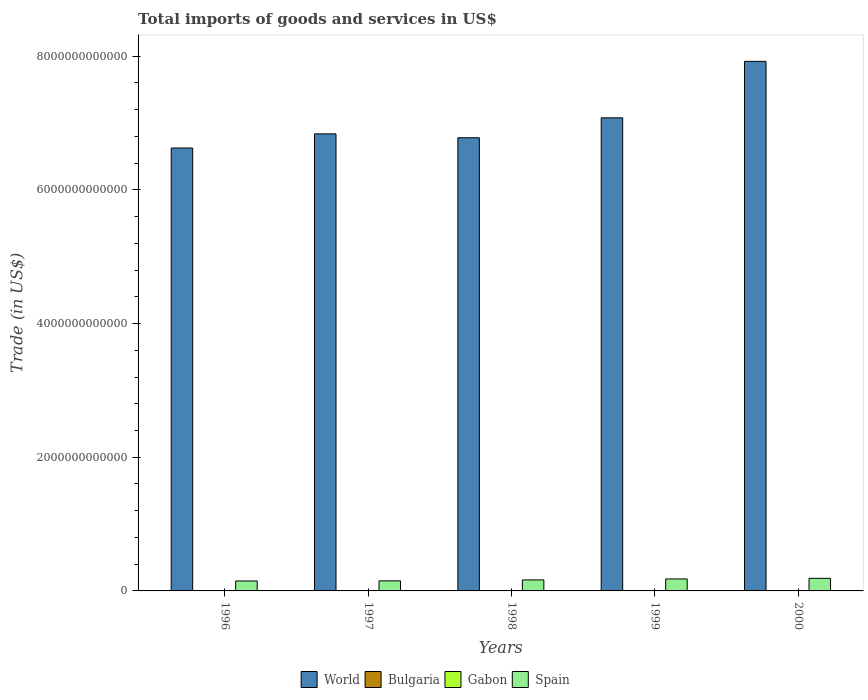How many different coloured bars are there?
Offer a terse response. 4. Are the number of bars per tick equal to the number of legend labels?
Offer a terse response. Yes. Are the number of bars on each tick of the X-axis equal?
Your answer should be compact. Yes. How many bars are there on the 4th tick from the left?
Your response must be concise. 4. How many bars are there on the 4th tick from the right?
Keep it short and to the point. 4. What is the label of the 4th group of bars from the left?
Keep it short and to the point. 1999. In how many cases, is the number of bars for a given year not equal to the number of legend labels?
Your response must be concise. 0. What is the total imports of goods and services in Gabon in 2000?
Offer a very short reply. 1.66e+09. Across all years, what is the maximum total imports of goods and services in Gabon?
Ensure brevity in your answer.  2.18e+09. Across all years, what is the minimum total imports of goods and services in World?
Your answer should be very brief. 6.63e+12. In which year was the total imports of goods and services in Spain maximum?
Give a very brief answer. 2000. What is the total total imports of goods and services in Bulgaria in the graph?
Provide a succinct answer. 2.60e+1. What is the difference between the total imports of goods and services in Bulgaria in 1997 and that in 1998?
Ensure brevity in your answer.  -1.10e+09. What is the difference between the total imports of goods and services in World in 1998 and the total imports of goods and services in Spain in 1996?
Give a very brief answer. 6.63e+12. What is the average total imports of goods and services in World per year?
Provide a succinct answer. 7.05e+12. In the year 2000, what is the difference between the total imports of goods and services in Spain and total imports of goods and services in Bulgaria?
Offer a terse response. 1.83e+11. What is the ratio of the total imports of goods and services in World in 1998 to that in 1999?
Provide a succinct answer. 0.96. Is the total imports of goods and services in Spain in 1998 less than that in 2000?
Your answer should be compact. Yes. Is the difference between the total imports of goods and services in Spain in 1996 and 1999 greater than the difference between the total imports of goods and services in Bulgaria in 1996 and 1999?
Provide a succinct answer. No. What is the difference between the highest and the second highest total imports of goods and services in Gabon?
Ensure brevity in your answer.  1.94e+08. What is the difference between the highest and the lowest total imports of goods and services in Bulgaria?
Make the answer very short. 2.27e+09. In how many years, is the total imports of goods and services in World greater than the average total imports of goods and services in World taken over all years?
Provide a short and direct response. 2. Is it the case that in every year, the sum of the total imports of goods and services in Spain and total imports of goods and services in World is greater than the sum of total imports of goods and services in Gabon and total imports of goods and services in Bulgaria?
Keep it short and to the point. Yes. What does the 3rd bar from the left in 1997 represents?
Your answer should be compact. Gabon. Is it the case that in every year, the sum of the total imports of goods and services in Bulgaria and total imports of goods and services in Gabon is greater than the total imports of goods and services in World?
Make the answer very short. No. What is the difference between two consecutive major ticks on the Y-axis?
Your answer should be compact. 2.00e+12. Does the graph contain any zero values?
Keep it short and to the point. No. How are the legend labels stacked?
Provide a succinct answer. Horizontal. What is the title of the graph?
Keep it short and to the point. Total imports of goods and services in US$. What is the label or title of the X-axis?
Offer a very short reply. Years. What is the label or title of the Y-axis?
Provide a succinct answer. Trade (in US$). What is the Trade (in US$) of World in 1996?
Provide a succinct answer. 6.63e+12. What is the Trade (in US$) of Bulgaria in 1996?
Make the answer very short. 4.59e+09. What is the Trade (in US$) of Gabon in 1996?
Your answer should be very brief. 1.88e+09. What is the Trade (in US$) of Spain in 1996?
Keep it short and to the point. 1.49e+11. What is the Trade (in US$) of World in 1997?
Your answer should be very brief. 6.84e+12. What is the Trade (in US$) of Bulgaria in 1997?
Your response must be concise. 4.17e+09. What is the Trade (in US$) in Gabon in 1997?
Give a very brief answer. 1.98e+09. What is the Trade (in US$) of Spain in 1997?
Your answer should be compact. 1.50e+11. What is the Trade (in US$) of World in 1998?
Provide a short and direct response. 6.78e+12. What is the Trade (in US$) in Bulgaria in 1998?
Your response must be concise. 5.28e+09. What is the Trade (in US$) in Gabon in 1998?
Your answer should be very brief. 2.18e+09. What is the Trade (in US$) in Spain in 1998?
Make the answer very short. 1.65e+11. What is the Trade (in US$) of World in 1999?
Keep it short and to the point. 7.08e+12. What is the Trade (in US$) of Bulgaria in 1999?
Keep it short and to the point. 6.45e+09. What is the Trade (in US$) in Gabon in 1999?
Make the answer very short. 1.78e+09. What is the Trade (in US$) of Spain in 1999?
Provide a short and direct response. 1.79e+11. What is the Trade (in US$) in World in 2000?
Give a very brief answer. 7.92e+12. What is the Trade (in US$) of Bulgaria in 2000?
Your answer should be compact. 5.50e+09. What is the Trade (in US$) of Gabon in 2000?
Offer a terse response. 1.66e+09. What is the Trade (in US$) in Spain in 2000?
Offer a very short reply. 1.88e+11. Across all years, what is the maximum Trade (in US$) of World?
Your answer should be very brief. 7.92e+12. Across all years, what is the maximum Trade (in US$) of Bulgaria?
Keep it short and to the point. 6.45e+09. Across all years, what is the maximum Trade (in US$) of Gabon?
Give a very brief answer. 2.18e+09. Across all years, what is the maximum Trade (in US$) in Spain?
Keep it short and to the point. 1.88e+11. Across all years, what is the minimum Trade (in US$) of World?
Offer a terse response. 6.63e+12. Across all years, what is the minimum Trade (in US$) in Bulgaria?
Offer a very short reply. 4.17e+09. Across all years, what is the minimum Trade (in US$) of Gabon?
Keep it short and to the point. 1.66e+09. Across all years, what is the minimum Trade (in US$) of Spain?
Offer a very short reply. 1.49e+11. What is the total Trade (in US$) of World in the graph?
Your answer should be compact. 3.52e+13. What is the total Trade (in US$) of Bulgaria in the graph?
Ensure brevity in your answer.  2.60e+1. What is the total Trade (in US$) of Gabon in the graph?
Your answer should be compact. 9.47e+09. What is the total Trade (in US$) of Spain in the graph?
Keep it short and to the point. 8.31e+11. What is the difference between the Trade (in US$) of World in 1996 and that in 1997?
Your answer should be compact. -2.12e+11. What is the difference between the Trade (in US$) in Bulgaria in 1996 and that in 1997?
Make the answer very short. 4.14e+08. What is the difference between the Trade (in US$) in Gabon in 1996 and that in 1997?
Keep it short and to the point. -1.04e+08. What is the difference between the Trade (in US$) in Spain in 1996 and that in 1997?
Your answer should be compact. -1.57e+09. What is the difference between the Trade (in US$) in World in 1996 and that in 1998?
Offer a terse response. -1.54e+11. What is the difference between the Trade (in US$) of Bulgaria in 1996 and that in 1998?
Make the answer very short. -6.88e+08. What is the difference between the Trade (in US$) of Gabon in 1996 and that in 1998?
Give a very brief answer. -2.98e+08. What is the difference between the Trade (in US$) in Spain in 1996 and that in 1998?
Your answer should be compact. -1.59e+1. What is the difference between the Trade (in US$) of World in 1996 and that in 1999?
Your answer should be compact. -4.52e+11. What is the difference between the Trade (in US$) of Bulgaria in 1996 and that in 1999?
Give a very brief answer. -1.86e+09. What is the difference between the Trade (in US$) in Gabon in 1996 and that in 1999?
Your answer should be compact. 1.02e+08. What is the difference between the Trade (in US$) in Spain in 1996 and that in 1999?
Provide a short and direct response. -3.07e+1. What is the difference between the Trade (in US$) in World in 1996 and that in 2000?
Your answer should be compact. -1.30e+12. What is the difference between the Trade (in US$) of Bulgaria in 1996 and that in 2000?
Offer a terse response. -9.12e+08. What is the difference between the Trade (in US$) of Gabon in 1996 and that in 2000?
Keep it short and to the point. 2.24e+08. What is the difference between the Trade (in US$) in Spain in 1996 and that in 2000?
Offer a terse response. -3.95e+1. What is the difference between the Trade (in US$) of World in 1997 and that in 1998?
Your response must be concise. 5.82e+1. What is the difference between the Trade (in US$) in Bulgaria in 1997 and that in 1998?
Offer a terse response. -1.10e+09. What is the difference between the Trade (in US$) in Gabon in 1997 and that in 1998?
Offer a very short reply. -1.94e+08. What is the difference between the Trade (in US$) in Spain in 1997 and that in 1998?
Your answer should be compact. -1.43e+1. What is the difference between the Trade (in US$) of World in 1997 and that in 1999?
Your response must be concise. -2.40e+11. What is the difference between the Trade (in US$) of Bulgaria in 1997 and that in 1999?
Offer a very short reply. -2.27e+09. What is the difference between the Trade (in US$) of Gabon in 1997 and that in 1999?
Provide a succinct answer. 2.06e+08. What is the difference between the Trade (in US$) in Spain in 1997 and that in 1999?
Provide a short and direct response. -2.91e+1. What is the difference between the Trade (in US$) in World in 1997 and that in 2000?
Your answer should be compact. -1.08e+12. What is the difference between the Trade (in US$) in Bulgaria in 1997 and that in 2000?
Give a very brief answer. -1.33e+09. What is the difference between the Trade (in US$) of Gabon in 1997 and that in 2000?
Your response must be concise. 3.28e+08. What is the difference between the Trade (in US$) in Spain in 1997 and that in 2000?
Provide a succinct answer. -3.79e+1. What is the difference between the Trade (in US$) in World in 1998 and that in 1999?
Give a very brief answer. -2.98e+11. What is the difference between the Trade (in US$) in Bulgaria in 1998 and that in 1999?
Offer a very short reply. -1.17e+09. What is the difference between the Trade (in US$) of Gabon in 1998 and that in 1999?
Your answer should be very brief. 4.00e+08. What is the difference between the Trade (in US$) in Spain in 1998 and that in 1999?
Give a very brief answer. -1.48e+1. What is the difference between the Trade (in US$) in World in 1998 and that in 2000?
Provide a succinct answer. -1.14e+12. What is the difference between the Trade (in US$) in Bulgaria in 1998 and that in 2000?
Offer a terse response. -2.24e+08. What is the difference between the Trade (in US$) in Gabon in 1998 and that in 2000?
Keep it short and to the point. 5.22e+08. What is the difference between the Trade (in US$) in Spain in 1998 and that in 2000?
Your answer should be very brief. -2.36e+1. What is the difference between the Trade (in US$) in World in 1999 and that in 2000?
Your response must be concise. -8.45e+11. What is the difference between the Trade (in US$) of Bulgaria in 1999 and that in 2000?
Give a very brief answer. 9.49e+08. What is the difference between the Trade (in US$) in Gabon in 1999 and that in 2000?
Keep it short and to the point. 1.22e+08. What is the difference between the Trade (in US$) of Spain in 1999 and that in 2000?
Offer a terse response. -8.82e+09. What is the difference between the Trade (in US$) of World in 1996 and the Trade (in US$) of Bulgaria in 1997?
Offer a very short reply. 6.62e+12. What is the difference between the Trade (in US$) in World in 1996 and the Trade (in US$) in Gabon in 1997?
Your response must be concise. 6.62e+12. What is the difference between the Trade (in US$) of World in 1996 and the Trade (in US$) of Spain in 1997?
Your answer should be compact. 6.48e+12. What is the difference between the Trade (in US$) in Bulgaria in 1996 and the Trade (in US$) in Gabon in 1997?
Keep it short and to the point. 2.61e+09. What is the difference between the Trade (in US$) in Bulgaria in 1996 and the Trade (in US$) in Spain in 1997?
Provide a succinct answer. -1.46e+11. What is the difference between the Trade (in US$) of Gabon in 1996 and the Trade (in US$) of Spain in 1997?
Ensure brevity in your answer.  -1.48e+11. What is the difference between the Trade (in US$) in World in 1996 and the Trade (in US$) in Bulgaria in 1998?
Make the answer very short. 6.62e+12. What is the difference between the Trade (in US$) in World in 1996 and the Trade (in US$) in Gabon in 1998?
Offer a terse response. 6.62e+12. What is the difference between the Trade (in US$) in World in 1996 and the Trade (in US$) in Spain in 1998?
Offer a very short reply. 6.46e+12. What is the difference between the Trade (in US$) in Bulgaria in 1996 and the Trade (in US$) in Gabon in 1998?
Make the answer very short. 2.41e+09. What is the difference between the Trade (in US$) in Bulgaria in 1996 and the Trade (in US$) in Spain in 1998?
Your answer should be compact. -1.60e+11. What is the difference between the Trade (in US$) in Gabon in 1996 and the Trade (in US$) in Spain in 1998?
Provide a succinct answer. -1.63e+11. What is the difference between the Trade (in US$) of World in 1996 and the Trade (in US$) of Bulgaria in 1999?
Your response must be concise. 6.62e+12. What is the difference between the Trade (in US$) of World in 1996 and the Trade (in US$) of Gabon in 1999?
Offer a very short reply. 6.62e+12. What is the difference between the Trade (in US$) in World in 1996 and the Trade (in US$) in Spain in 1999?
Ensure brevity in your answer.  6.45e+12. What is the difference between the Trade (in US$) of Bulgaria in 1996 and the Trade (in US$) of Gabon in 1999?
Make the answer very short. 2.81e+09. What is the difference between the Trade (in US$) of Bulgaria in 1996 and the Trade (in US$) of Spain in 1999?
Your answer should be very brief. -1.75e+11. What is the difference between the Trade (in US$) in Gabon in 1996 and the Trade (in US$) in Spain in 1999?
Keep it short and to the point. -1.78e+11. What is the difference between the Trade (in US$) in World in 1996 and the Trade (in US$) in Bulgaria in 2000?
Give a very brief answer. 6.62e+12. What is the difference between the Trade (in US$) of World in 1996 and the Trade (in US$) of Gabon in 2000?
Your answer should be compact. 6.62e+12. What is the difference between the Trade (in US$) of World in 1996 and the Trade (in US$) of Spain in 2000?
Ensure brevity in your answer.  6.44e+12. What is the difference between the Trade (in US$) of Bulgaria in 1996 and the Trade (in US$) of Gabon in 2000?
Keep it short and to the point. 2.93e+09. What is the difference between the Trade (in US$) in Bulgaria in 1996 and the Trade (in US$) in Spain in 2000?
Provide a succinct answer. -1.84e+11. What is the difference between the Trade (in US$) in Gabon in 1996 and the Trade (in US$) in Spain in 2000?
Your answer should be compact. -1.86e+11. What is the difference between the Trade (in US$) of World in 1997 and the Trade (in US$) of Bulgaria in 1998?
Provide a succinct answer. 6.83e+12. What is the difference between the Trade (in US$) in World in 1997 and the Trade (in US$) in Gabon in 1998?
Provide a succinct answer. 6.84e+12. What is the difference between the Trade (in US$) in World in 1997 and the Trade (in US$) in Spain in 1998?
Ensure brevity in your answer.  6.67e+12. What is the difference between the Trade (in US$) of Bulgaria in 1997 and the Trade (in US$) of Gabon in 1998?
Your response must be concise. 2.00e+09. What is the difference between the Trade (in US$) in Bulgaria in 1997 and the Trade (in US$) in Spain in 1998?
Your answer should be very brief. -1.60e+11. What is the difference between the Trade (in US$) in Gabon in 1997 and the Trade (in US$) in Spain in 1998?
Your answer should be compact. -1.63e+11. What is the difference between the Trade (in US$) of World in 1997 and the Trade (in US$) of Bulgaria in 1999?
Keep it short and to the point. 6.83e+12. What is the difference between the Trade (in US$) in World in 1997 and the Trade (in US$) in Gabon in 1999?
Provide a succinct answer. 6.84e+12. What is the difference between the Trade (in US$) in World in 1997 and the Trade (in US$) in Spain in 1999?
Your answer should be compact. 6.66e+12. What is the difference between the Trade (in US$) of Bulgaria in 1997 and the Trade (in US$) of Gabon in 1999?
Ensure brevity in your answer.  2.40e+09. What is the difference between the Trade (in US$) of Bulgaria in 1997 and the Trade (in US$) of Spain in 1999?
Your answer should be very brief. -1.75e+11. What is the difference between the Trade (in US$) in Gabon in 1997 and the Trade (in US$) in Spain in 1999?
Make the answer very short. -1.77e+11. What is the difference between the Trade (in US$) of World in 1997 and the Trade (in US$) of Bulgaria in 2000?
Make the answer very short. 6.83e+12. What is the difference between the Trade (in US$) of World in 1997 and the Trade (in US$) of Gabon in 2000?
Your response must be concise. 6.84e+12. What is the difference between the Trade (in US$) of World in 1997 and the Trade (in US$) of Spain in 2000?
Offer a very short reply. 6.65e+12. What is the difference between the Trade (in US$) in Bulgaria in 1997 and the Trade (in US$) in Gabon in 2000?
Your answer should be very brief. 2.52e+09. What is the difference between the Trade (in US$) in Bulgaria in 1997 and the Trade (in US$) in Spain in 2000?
Your answer should be compact. -1.84e+11. What is the difference between the Trade (in US$) of Gabon in 1997 and the Trade (in US$) of Spain in 2000?
Give a very brief answer. -1.86e+11. What is the difference between the Trade (in US$) in World in 1998 and the Trade (in US$) in Bulgaria in 1999?
Provide a short and direct response. 6.77e+12. What is the difference between the Trade (in US$) of World in 1998 and the Trade (in US$) of Gabon in 1999?
Give a very brief answer. 6.78e+12. What is the difference between the Trade (in US$) of World in 1998 and the Trade (in US$) of Spain in 1999?
Make the answer very short. 6.60e+12. What is the difference between the Trade (in US$) of Bulgaria in 1998 and the Trade (in US$) of Gabon in 1999?
Keep it short and to the point. 3.50e+09. What is the difference between the Trade (in US$) in Bulgaria in 1998 and the Trade (in US$) in Spain in 1999?
Give a very brief answer. -1.74e+11. What is the difference between the Trade (in US$) of Gabon in 1998 and the Trade (in US$) of Spain in 1999?
Make the answer very short. -1.77e+11. What is the difference between the Trade (in US$) in World in 1998 and the Trade (in US$) in Bulgaria in 2000?
Offer a very short reply. 6.77e+12. What is the difference between the Trade (in US$) of World in 1998 and the Trade (in US$) of Gabon in 2000?
Your answer should be compact. 6.78e+12. What is the difference between the Trade (in US$) of World in 1998 and the Trade (in US$) of Spain in 2000?
Your response must be concise. 6.59e+12. What is the difference between the Trade (in US$) in Bulgaria in 1998 and the Trade (in US$) in Gabon in 2000?
Your answer should be compact. 3.62e+09. What is the difference between the Trade (in US$) of Bulgaria in 1998 and the Trade (in US$) of Spain in 2000?
Your answer should be compact. -1.83e+11. What is the difference between the Trade (in US$) in Gabon in 1998 and the Trade (in US$) in Spain in 2000?
Provide a short and direct response. -1.86e+11. What is the difference between the Trade (in US$) in World in 1999 and the Trade (in US$) in Bulgaria in 2000?
Offer a very short reply. 7.07e+12. What is the difference between the Trade (in US$) of World in 1999 and the Trade (in US$) of Gabon in 2000?
Provide a short and direct response. 7.08e+12. What is the difference between the Trade (in US$) of World in 1999 and the Trade (in US$) of Spain in 2000?
Provide a short and direct response. 6.89e+12. What is the difference between the Trade (in US$) of Bulgaria in 1999 and the Trade (in US$) of Gabon in 2000?
Your response must be concise. 4.79e+09. What is the difference between the Trade (in US$) in Bulgaria in 1999 and the Trade (in US$) in Spain in 2000?
Your answer should be very brief. -1.82e+11. What is the difference between the Trade (in US$) of Gabon in 1999 and the Trade (in US$) of Spain in 2000?
Your answer should be compact. -1.86e+11. What is the average Trade (in US$) in World per year?
Offer a terse response. 7.05e+12. What is the average Trade (in US$) in Bulgaria per year?
Ensure brevity in your answer.  5.20e+09. What is the average Trade (in US$) of Gabon per year?
Offer a very short reply. 1.89e+09. What is the average Trade (in US$) in Spain per year?
Offer a terse response. 1.66e+11. In the year 1996, what is the difference between the Trade (in US$) of World and Trade (in US$) of Bulgaria?
Keep it short and to the point. 6.62e+12. In the year 1996, what is the difference between the Trade (in US$) in World and Trade (in US$) in Gabon?
Make the answer very short. 6.62e+12. In the year 1996, what is the difference between the Trade (in US$) of World and Trade (in US$) of Spain?
Make the answer very short. 6.48e+12. In the year 1996, what is the difference between the Trade (in US$) in Bulgaria and Trade (in US$) in Gabon?
Ensure brevity in your answer.  2.71e+09. In the year 1996, what is the difference between the Trade (in US$) of Bulgaria and Trade (in US$) of Spain?
Your answer should be compact. -1.44e+11. In the year 1996, what is the difference between the Trade (in US$) in Gabon and Trade (in US$) in Spain?
Provide a succinct answer. -1.47e+11. In the year 1997, what is the difference between the Trade (in US$) in World and Trade (in US$) in Bulgaria?
Offer a terse response. 6.83e+12. In the year 1997, what is the difference between the Trade (in US$) in World and Trade (in US$) in Gabon?
Make the answer very short. 6.84e+12. In the year 1997, what is the difference between the Trade (in US$) of World and Trade (in US$) of Spain?
Offer a very short reply. 6.69e+12. In the year 1997, what is the difference between the Trade (in US$) of Bulgaria and Trade (in US$) of Gabon?
Give a very brief answer. 2.19e+09. In the year 1997, what is the difference between the Trade (in US$) of Bulgaria and Trade (in US$) of Spain?
Provide a short and direct response. -1.46e+11. In the year 1997, what is the difference between the Trade (in US$) of Gabon and Trade (in US$) of Spain?
Offer a terse response. -1.48e+11. In the year 1998, what is the difference between the Trade (in US$) of World and Trade (in US$) of Bulgaria?
Keep it short and to the point. 6.77e+12. In the year 1998, what is the difference between the Trade (in US$) in World and Trade (in US$) in Gabon?
Offer a very short reply. 6.78e+12. In the year 1998, what is the difference between the Trade (in US$) of World and Trade (in US$) of Spain?
Give a very brief answer. 6.61e+12. In the year 1998, what is the difference between the Trade (in US$) in Bulgaria and Trade (in US$) in Gabon?
Your answer should be compact. 3.10e+09. In the year 1998, what is the difference between the Trade (in US$) of Bulgaria and Trade (in US$) of Spain?
Ensure brevity in your answer.  -1.59e+11. In the year 1998, what is the difference between the Trade (in US$) of Gabon and Trade (in US$) of Spain?
Ensure brevity in your answer.  -1.62e+11. In the year 1999, what is the difference between the Trade (in US$) of World and Trade (in US$) of Bulgaria?
Make the answer very short. 7.07e+12. In the year 1999, what is the difference between the Trade (in US$) of World and Trade (in US$) of Gabon?
Offer a very short reply. 7.08e+12. In the year 1999, what is the difference between the Trade (in US$) of World and Trade (in US$) of Spain?
Your answer should be very brief. 6.90e+12. In the year 1999, what is the difference between the Trade (in US$) in Bulgaria and Trade (in US$) in Gabon?
Your answer should be very brief. 4.67e+09. In the year 1999, what is the difference between the Trade (in US$) in Bulgaria and Trade (in US$) in Spain?
Give a very brief answer. -1.73e+11. In the year 1999, what is the difference between the Trade (in US$) of Gabon and Trade (in US$) of Spain?
Your response must be concise. -1.78e+11. In the year 2000, what is the difference between the Trade (in US$) in World and Trade (in US$) in Bulgaria?
Your answer should be very brief. 7.92e+12. In the year 2000, what is the difference between the Trade (in US$) in World and Trade (in US$) in Gabon?
Your answer should be very brief. 7.92e+12. In the year 2000, what is the difference between the Trade (in US$) in World and Trade (in US$) in Spain?
Give a very brief answer. 7.73e+12. In the year 2000, what is the difference between the Trade (in US$) of Bulgaria and Trade (in US$) of Gabon?
Make the answer very short. 3.84e+09. In the year 2000, what is the difference between the Trade (in US$) in Bulgaria and Trade (in US$) in Spain?
Make the answer very short. -1.83e+11. In the year 2000, what is the difference between the Trade (in US$) in Gabon and Trade (in US$) in Spain?
Provide a short and direct response. -1.87e+11. What is the ratio of the Trade (in US$) in World in 1996 to that in 1997?
Offer a terse response. 0.97. What is the ratio of the Trade (in US$) of Bulgaria in 1996 to that in 1997?
Your answer should be compact. 1.1. What is the ratio of the Trade (in US$) of Gabon in 1996 to that in 1997?
Offer a terse response. 0.95. What is the ratio of the Trade (in US$) in Spain in 1996 to that in 1997?
Provide a succinct answer. 0.99. What is the ratio of the Trade (in US$) of World in 1996 to that in 1998?
Your answer should be compact. 0.98. What is the ratio of the Trade (in US$) of Bulgaria in 1996 to that in 1998?
Your answer should be compact. 0.87. What is the ratio of the Trade (in US$) in Gabon in 1996 to that in 1998?
Give a very brief answer. 0.86. What is the ratio of the Trade (in US$) of Spain in 1996 to that in 1998?
Ensure brevity in your answer.  0.9. What is the ratio of the Trade (in US$) of World in 1996 to that in 1999?
Offer a terse response. 0.94. What is the ratio of the Trade (in US$) in Bulgaria in 1996 to that in 1999?
Offer a very short reply. 0.71. What is the ratio of the Trade (in US$) of Gabon in 1996 to that in 1999?
Make the answer very short. 1.06. What is the ratio of the Trade (in US$) of Spain in 1996 to that in 1999?
Provide a succinct answer. 0.83. What is the ratio of the Trade (in US$) in World in 1996 to that in 2000?
Your answer should be compact. 0.84. What is the ratio of the Trade (in US$) in Bulgaria in 1996 to that in 2000?
Provide a short and direct response. 0.83. What is the ratio of the Trade (in US$) in Gabon in 1996 to that in 2000?
Offer a very short reply. 1.14. What is the ratio of the Trade (in US$) in Spain in 1996 to that in 2000?
Offer a very short reply. 0.79. What is the ratio of the Trade (in US$) of World in 1997 to that in 1998?
Ensure brevity in your answer.  1.01. What is the ratio of the Trade (in US$) in Bulgaria in 1997 to that in 1998?
Your answer should be compact. 0.79. What is the ratio of the Trade (in US$) in Gabon in 1997 to that in 1998?
Offer a terse response. 0.91. What is the ratio of the Trade (in US$) of Spain in 1997 to that in 1998?
Your answer should be compact. 0.91. What is the ratio of the Trade (in US$) of World in 1997 to that in 1999?
Make the answer very short. 0.97. What is the ratio of the Trade (in US$) in Bulgaria in 1997 to that in 1999?
Keep it short and to the point. 0.65. What is the ratio of the Trade (in US$) of Gabon in 1997 to that in 1999?
Ensure brevity in your answer.  1.12. What is the ratio of the Trade (in US$) of Spain in 1997 to that in 1999?
Give a very brief answer. 0.84. What is the ratio of the Trade (in US$) of World in 1997 to that in 2000?
Offer a terse response. 0.86. What is the ratio of the Trade (in US$) of Bulgaria in 1997 to that in 2000?
Ensure brevity in your answer.  0.76. What is the ratio of the Trade (in US$) in Gabon in 1997 to that in 2000?
Make the answer very short. 1.2. What is the ratio of the Trade (in US$) in Spain in 1997 to that in 2000?
Offer a very short reply. 0.8. What is the ratio of the Trade (in US$) in World in 1998 to that in 1999?
Keep it short and to the point. 0.96. What is the ratio of the Trade (in US$) in Bulgaria in 1998 to that in 1999?
Provide a short and direct response. 0.82. What is the ratio of the Trade (in US$) in Gabon in 1998 to that in 1999?
Ensure brevity in your answer.  1.23. What is the ratio of the Trade (in US$) of Spain in 1998 to that in 1999?
Offer a terse response. 0.92. What is the ratio of the Trade (in US$) in World in 1998 to that in 2000?
Offer a very short reply. 0.86. What is the ratio of the Trade (in US$) of Bulgaria in 1998 to that in 2000?
Keep it short and to the point. 0.96. What is the ratio of the Trade (in US$) in Gabon in 1998 to that in 2000?
Make the answer very short. 1.32. What is the ratio of the Trade (in US$) in Spain in 1998 to that in 2000?
Make the answer very short. 0.87. What is the ratio of the Trade (in US$) of World in 1999 to that in 2000?
Keep it short and to the point. 0.89. What is the ratio of the Trade (in US$) in Bulgaria in 1999 to that in 2000?
Provide a succinct answer. 1.17. What is the ratio of the Trade (in US$) in Gabon in 1999 to that in 2000?
Keep it short and to the point. 1.07. What is the ratio of the Trade (in US$) in Spain in 1999 to that in 2000?
Provide a succinct answer. 0.95. What is the difference between the highest and the second highest Trade (in US$) in World?
Your answer should be very brief. 8.45e+11. What is the difference between the highest and the second highest Trade (in US$) in Bulgaria?
Your answer should be compact. 9.49e+08. What is the difference between the highest and the second highest Trade (in US$) of Gabon?
Your response must be concise. 1.94e+08. What is the difference between the highest and the second highest Trade (in US$) in Spain?
Give a very brief answer. 8.82e+09. What is the difference between the highest and the lowest Trade (in US$) in World?
Keep it short and to the point. 1.30e+12. What is the difference between the highest and the lowest Trade (in US$) in Bulgaria?
Make the answer very short. 2.27e+09. What is the difference between the highest and the lowest Trade (in US$) in Gabon?
Give a very brief answer. 5.22e+08. What is the difference between the highest and the lowest Trade (in US$) of Spain?
Make the answer very short. 3.95e+1. 